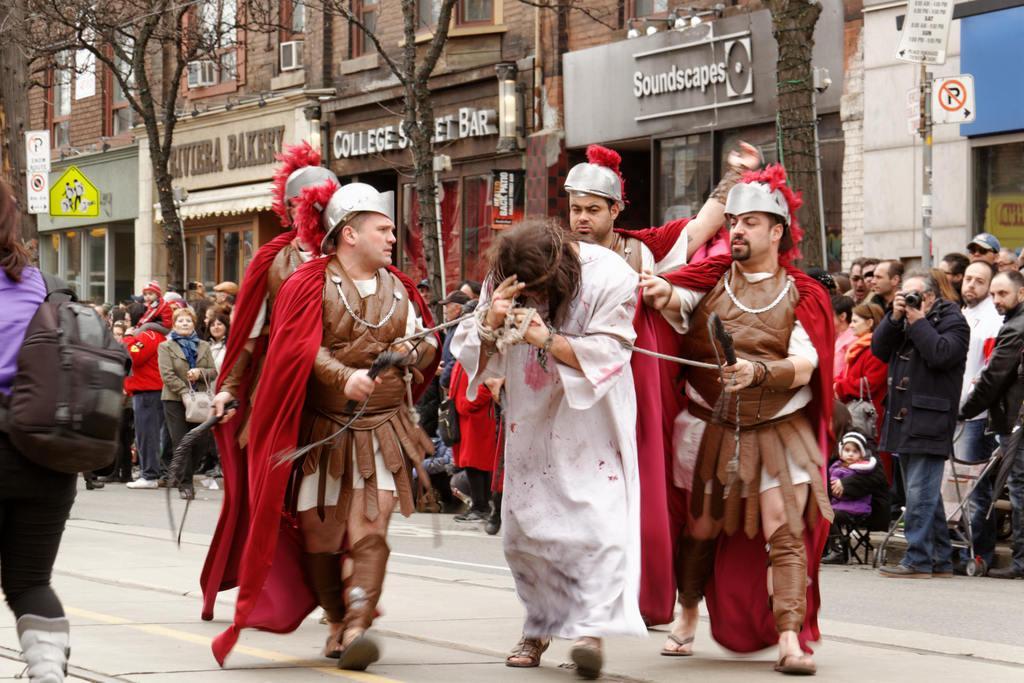How would you summarize this image in a sentence or two? In this picture we can see the man wearing a white dress and walking on the road. Beside we can see some soldiers, tired him with ropes. Behind we can see a group of people standing and watching him and taking photos. In the background we can see some shops, buildings and dry trees. 